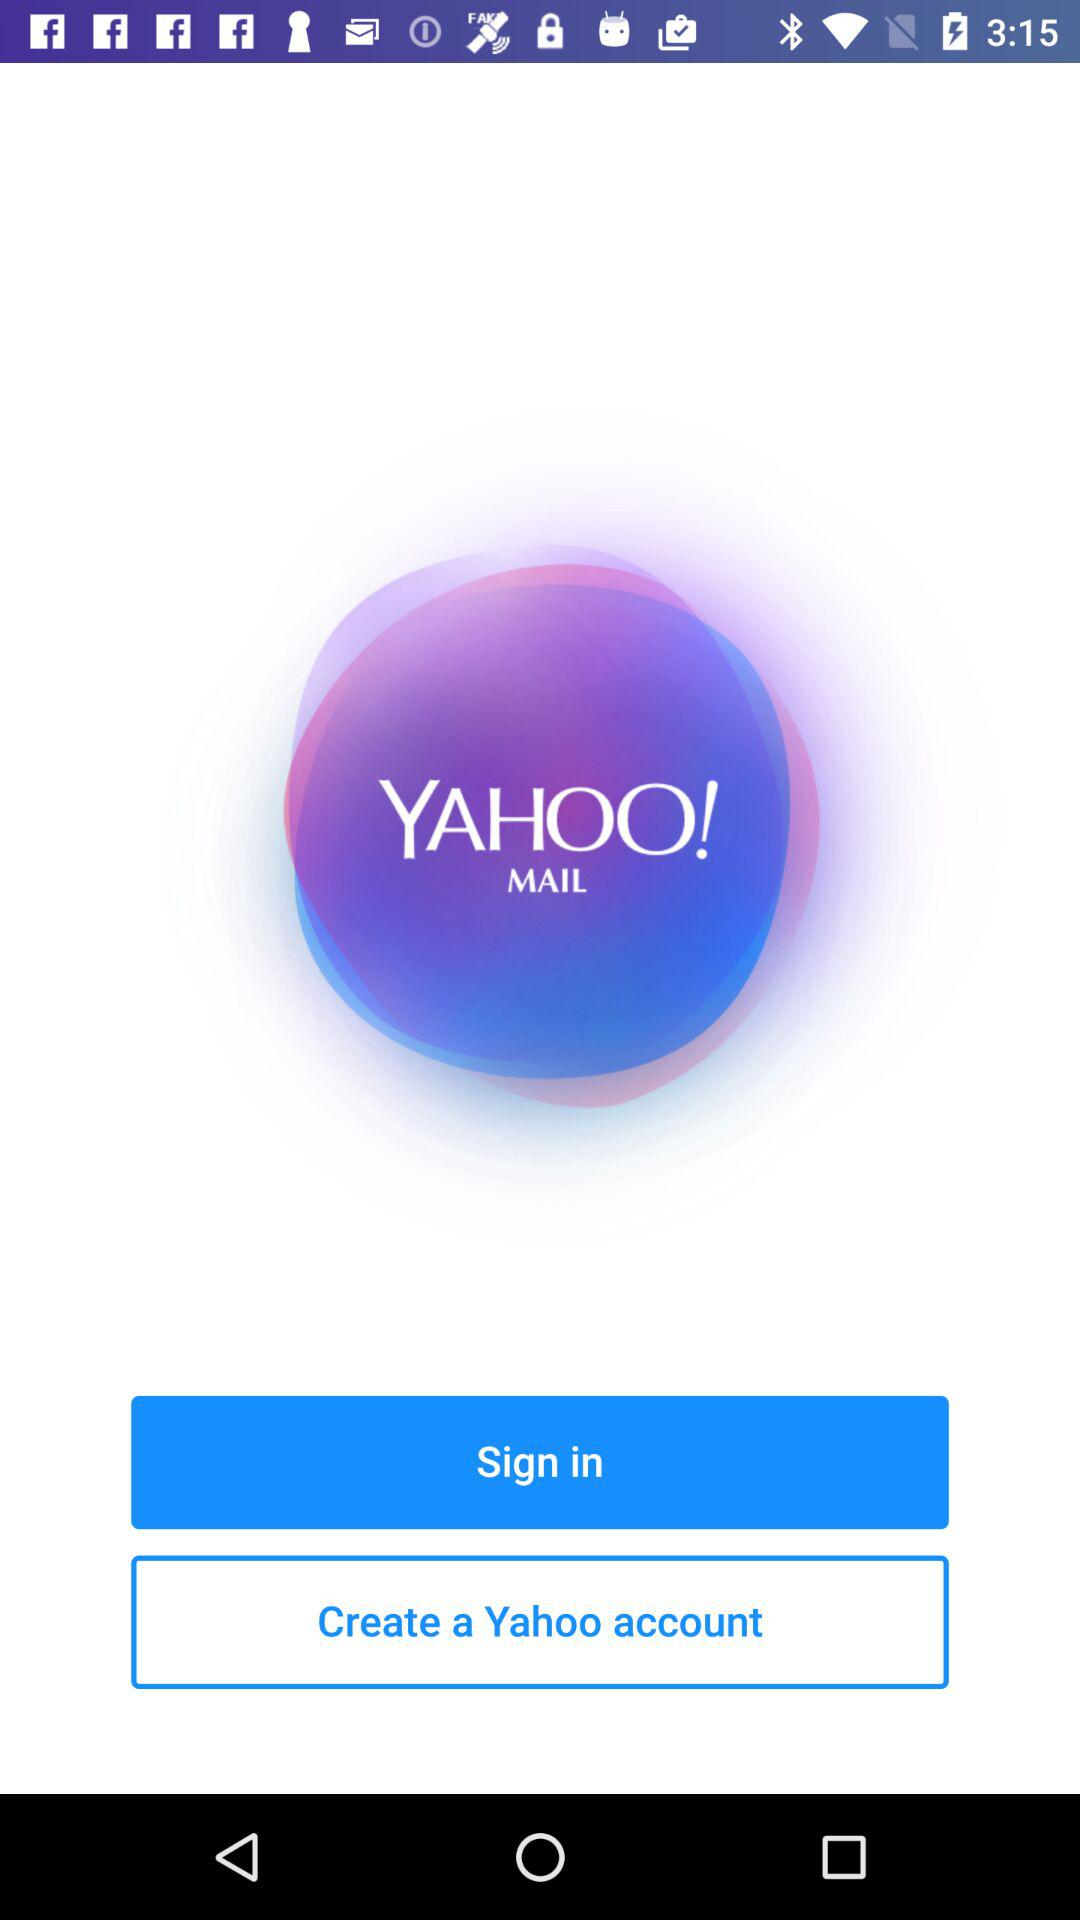What is the application name? The application name is "YAHOO! MAIL". 